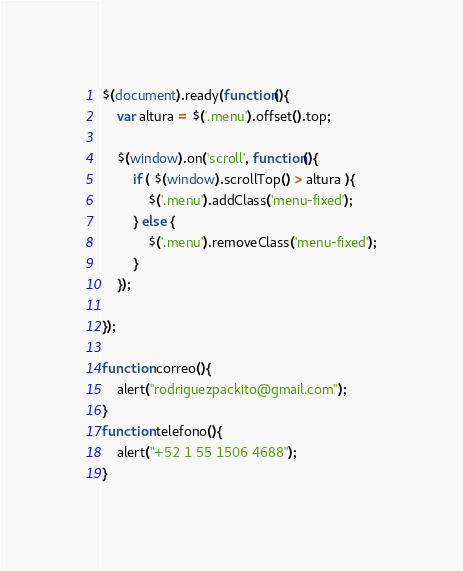Convert code to text. <code><loc_0><loc_0><loc_500><loc_500><_JavaScript_>$(document).ready(function(){
	var altura = $('.menu').offset().top;
	
	$(window).on('scroll', function(){
		if ( $(window).scrollTop() > altura ){
			$('.menu').addClass('menu-fixed');
		} else {
			$('.menu').removeClass('menu-fixed');
		}
	});
 
});

function correo(){
	alert("rodriguezpackito@gmail.com");
}
function telefono(){
	alert("+52 1 55 1506 4688");
}</code> 